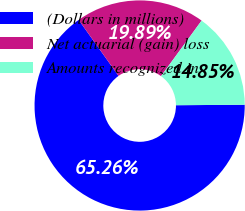Convert chart. <chart><loc_0><loc_0><loc_500><loc_500><pie_chart><fcel>(Dollars in millions)<fcel>Net actuarial (gain) loss<fcel>Amounts recognized in<nl><fcel>65.27%<fcel>19.89%<fcel>14.85%<nl></chart> 